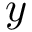<formula> <loc_0><loc_0><loc_500><loc_500>y</formula> 